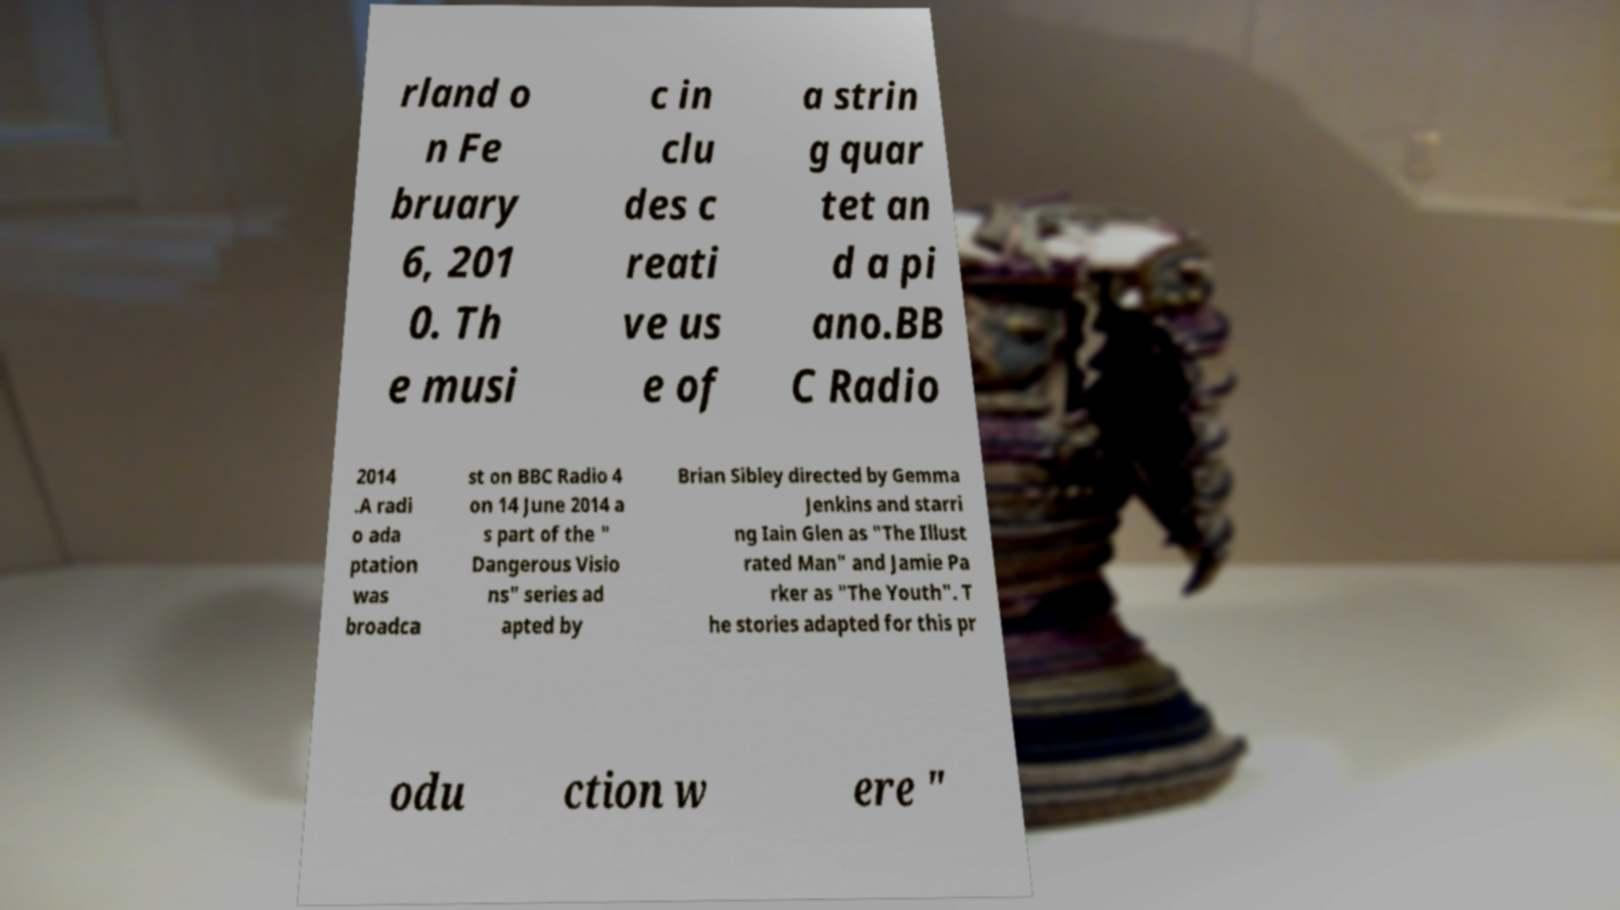Can you accurately transcribe the text from the provided image for me? rland o n Fe bruary 6, 201 0. Th e musi c in clu des c reati ve us e of a strin g quar tet an d a pi ano.BB C Radio 2014 .A radi o ada ptation was broadca st on BBC Radio 4 on 14 June 2014 a s part of the " Dangerous Visio ns" series ad apted by Brian Sibley directed by Gemma Jenkins and starri ng Iain Glen as "The Illust rated Man" and Jamie Pa rker as "The Youth". T he stories adapted for this pr odu ction w ere " 